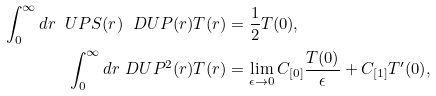<formula> <loc_0><loc_0><loc_500><loc_500>\int _ { 0 } ^ { \infty } d r \ U P S ( r ) \ D U P ( r ) T ( r ) & = \frac { 1 } { 2 } T ( 0 ) , \\ \int _ { 0 } ^ { \infty } d r \ D U P ^ { 2 } ( r ) T ( r ) & = \lim _ { \epsilon \rightarrow 0 } C _ { [ 0 ] } \frac { T ( 0 ) } { \epsilon } + C _ { [ 1 ] } { T ^ { \prime } ( 0 ) } ,</formula> 